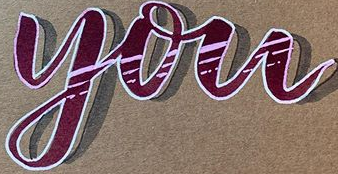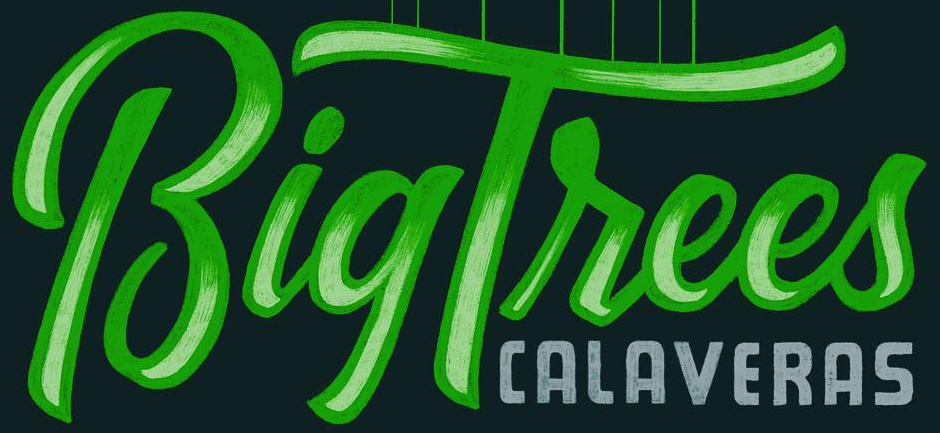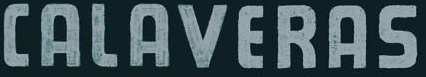What words are shown in these images in order, separated by a semicolon? you; BigTrees; CALAVERAS 